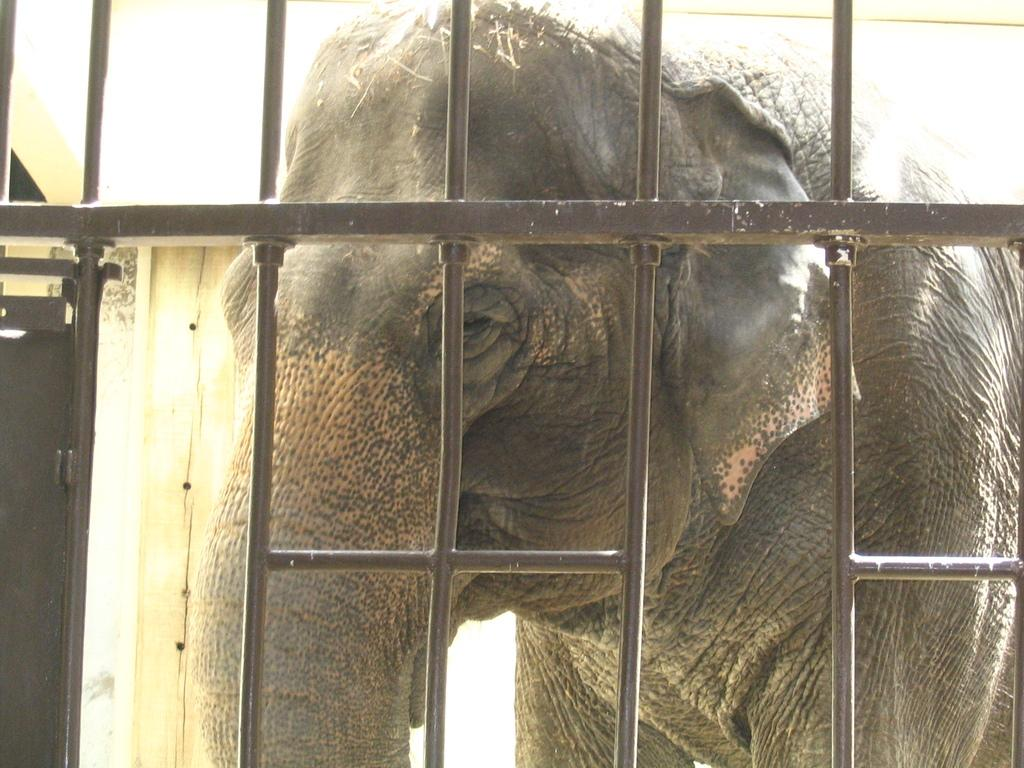What animal is present in the image? There is an elephant in the image. What is in front of the elephant? There is a gate in front of the elephant. What structure is located behind the elephant? There is a house behind the elephant. What position does the elephant hold in the image? The elephant does not hold a position in the image; it is an animal. 